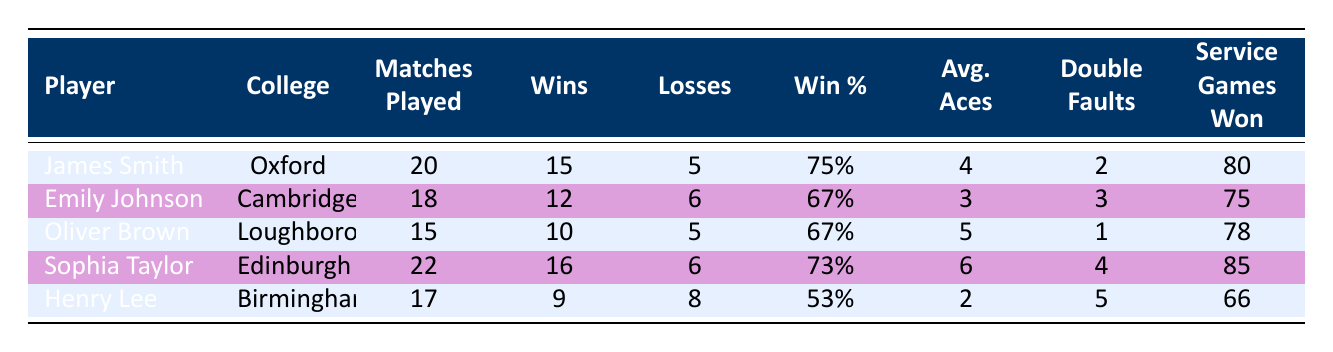What is the win percentage of James Smith? James Smith's win percentage is found directly in the table under the "Win %" column. The value listed next to his name is 75%.
Answer: 75% Which player had the highest average aces per match? To find the player with the highest average aces, I compare the values in the "Avg. Aces" column. Sophia Taylor has the highest value at 6.
Answer: 6 How many matches did Henry Lee play and how many did he win? The table lists Henry Lee's matches played as 17 and wins as 9. These values can be found directly in the table's respective columns.
Answer: 17 matches, 9 wins What is the win percentage difference between Sophia Taylor and Emily Johnson? First, I find their win percentages: Sophia Taylor’s is 73% and Emily Johnson’s is 67%. The difference is calculated as 73% - 67% = 6%.
Answer: 6% Did any player record more service games won than matches played? By checking the "Service Games Won" for each player, Sophia Taylor won 85 service games, which is greater than her matches played (22). This indicates a 'yes' answer.
Answer: Yes Which player has the fewest double faults and what is that number? Looking at the "Double Faults" column, the lowest number is 1, associated with Oliver Brown. Thus, he has the least double faults.
Answer: 1 How many total wins did the players from the University of Oxford and University of Cambridge combine? Adding the wins from James Smith (15) and Emily Johnson (12): 15 + 12 = 27 total wins combined.
Answer: 27 Is Henry Lee's win percentage lower than 60%? Henry Lee's win percentage of 53% is found in the table, which is indeed lower than 60%. This confirms a 'yes' answer.
Answer: Yes What is the average win percentage of the players listed in the table? To find the average win percentage, sum the individual percentages (75% + 67% + 67% + 73% + 53%) = 405% and divide by the number of players (5). So, 405% / 5 = 81%.
Answer: 81% 